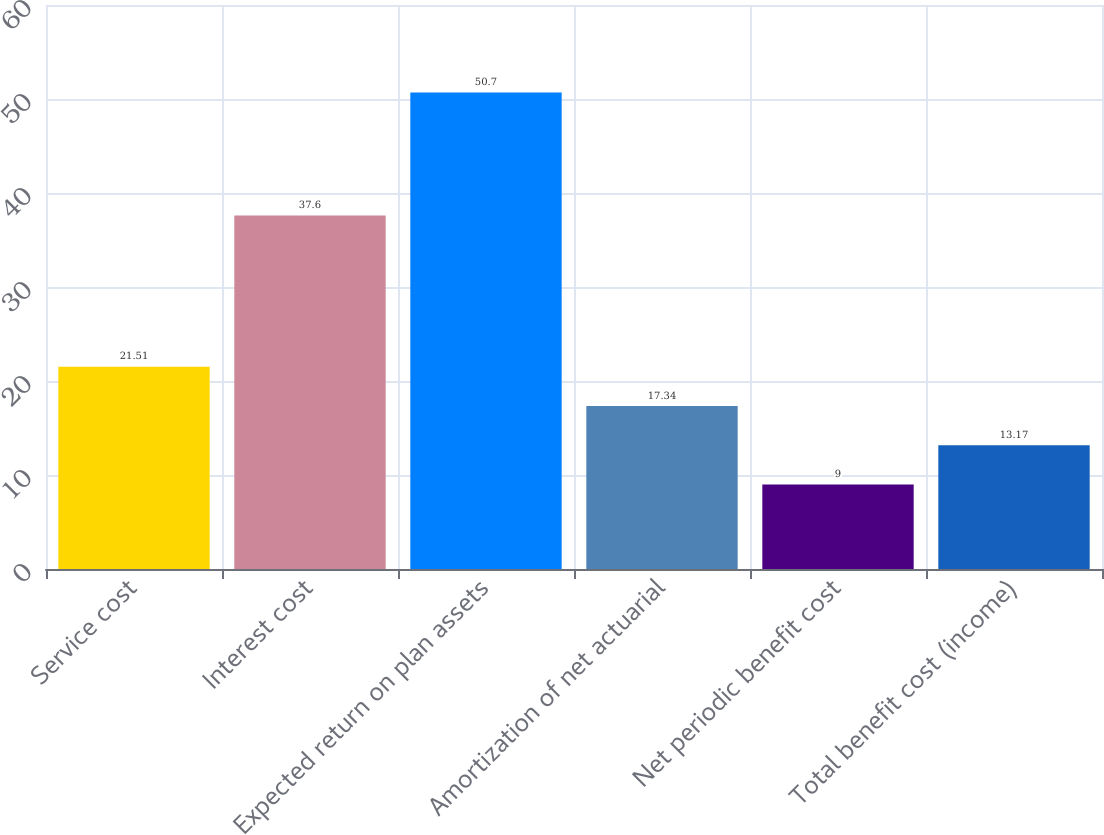<chart> <loc_0><loc_0><loc_500><loc_500><bar_chart><fcel>Service cost<fcel>Interest cost<fcel>Expected return on plan assets<fcel>Amortization of net actuarial<fcel>Net periodic benefit cost<fcel>Total benefit cost (income)<nl><fcel>21.51<fcel>37.6<fcel>50.7<fcel>17.34<fcel>9<fcel>13.17<nl></chart> 